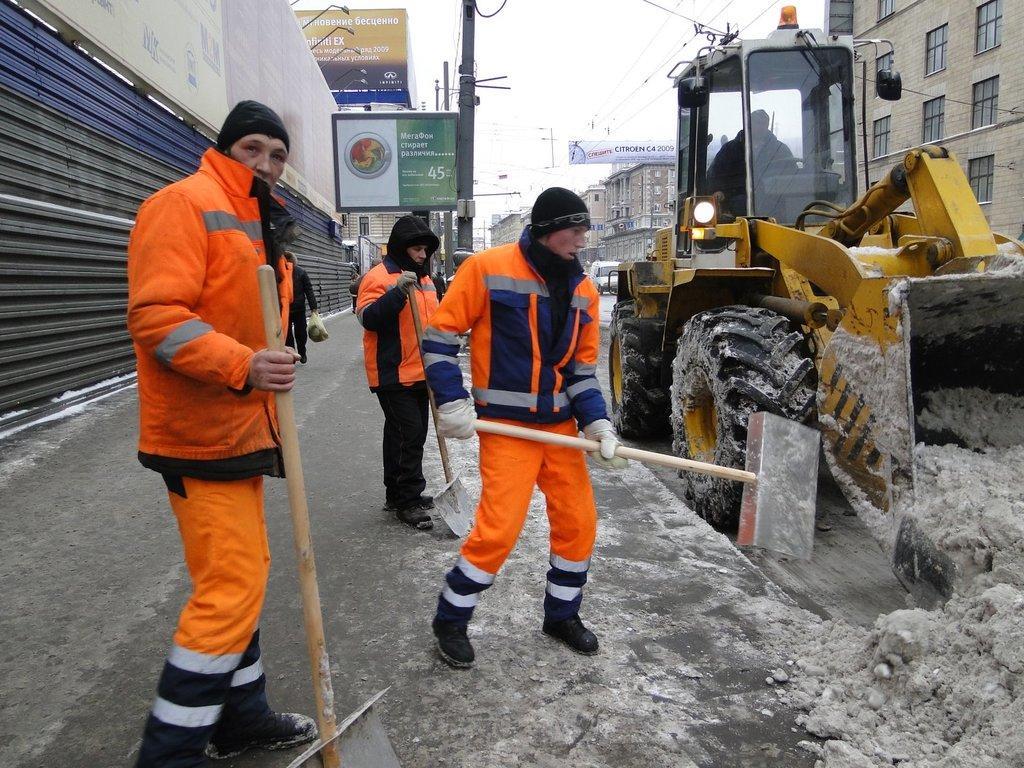How would you summarize this image in a sentence or two? In this image we can see a few people, three of them are holding shovels, one person is holding a package, another person is driving a backhoe loader, there is a mud, there are buildings, poles, wires, there are shutters, also we can see the sky, and there are boards with some text on it. 